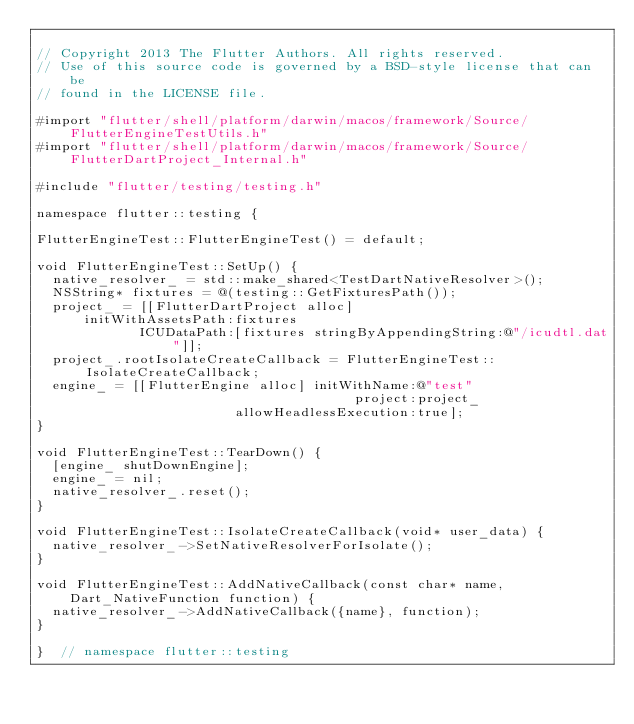Convert code to text. <code><loc_0><loc_0><loc_500><loc_500><_ObjectiveC_>
// Copyright 2013 The Flutter Authors. All rights reserved.
// Use of this source code is governed by a BSD-style license that can be
// found in the LICENSE file.

#import "flutter/shell/platform/darwin/macos/framework/Source/FlutterEngineTestUtils.h"
#import "flutter/shell/platform/darwin/macos/framework/Source/FlutterDartProject_Internal.h"

#include "flutter/testing/testing.h"

namespace flutter::testing {

FlutterEngineTest::FlutterEngineTest() = default;

void FlutterEngineTest::SetUp() {
  native_resolver_ = std::make_shared<TestDartNativeResolver>();
  NSString* fixtures = @(testing::GetFixturesPath());
  project_ = [[FlutterDartProject alloc]
      initWithAssetsPath:fixtures
             ICUDataPath:[fixtures stringByAppendingString:@"/icudtl.dat"]];
  project_.rootIsolateCreateCallback = FlutterEngineTest::IsolateCreateCallback;
  engine_ = [[FlutterEngine alloc] initWithName:@"test"
                                        project:project_
                         allowHeadlessExecution:true];
}

void FlutterEngineTest::TearDown() {
  [engine_ shutDownEngine];
  engine_ = nil;
  native_resolver_.reset();
}

void FlutterEngineTest::IsolateCreateCallback(void* user_data) {
  native_resolver_->SetNativeResolverForIsolate();
}

void FlutterEngineTest::AddNativeCallback(const char* name, Dart_NativeFunction function) {
  native_resolver_->AddNativeCallback({name}, function);
}

}  // namespace flutter::testing
</code> 